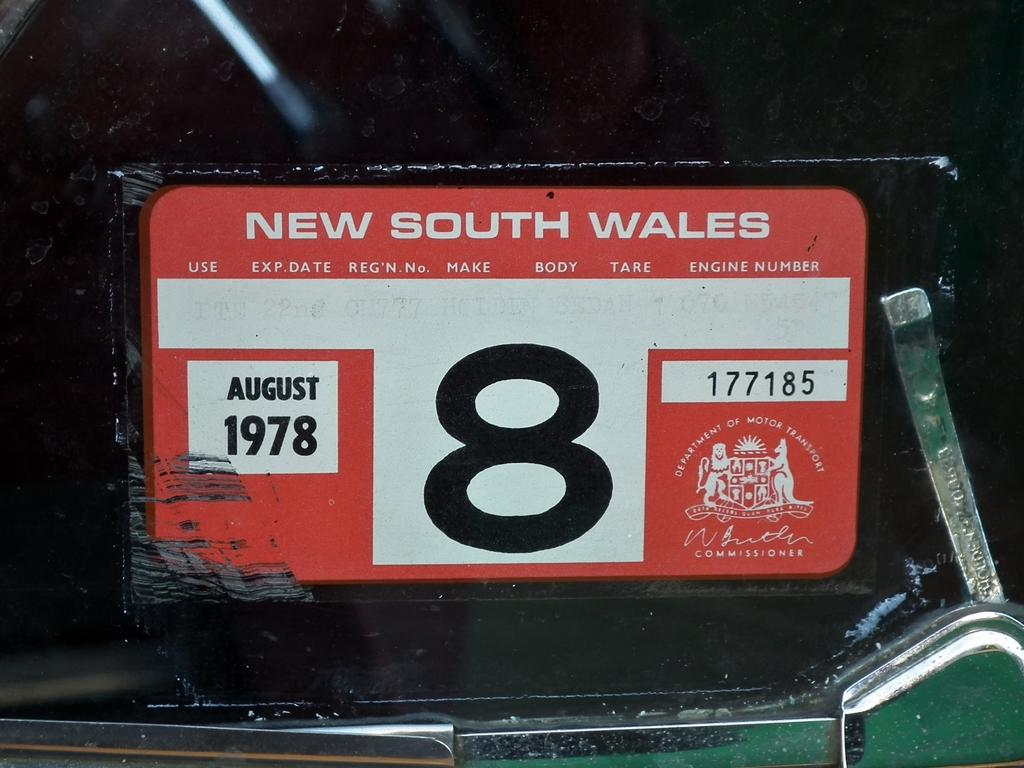<image>
Render a clear and concise summary of the photo. a new south wales license plate with the number 8 